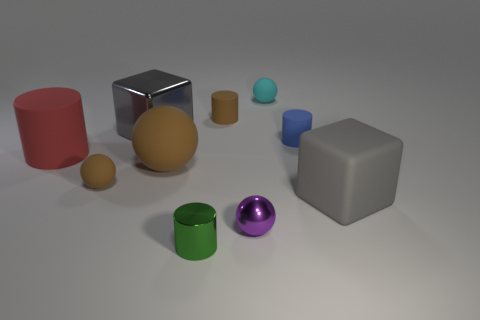Subtract all shiny spheres. How many spheres are left? 3 Subtract all green cylinders. How many cylinders are left? 3 Subtract all cylinders. How many objects are left? 6 Subtract all small cyan rubber things. Subtract all blocks. How many objects are left? 7 Add 9 big red things. How many big red things are left? 10 Add 6 large red cylinders. How many large red cylinders exist? 7 Subtract 1 red cylinders. How many objects are left? 9 Subtract 1 cubes. How many cubes are left? 1 Subtract all gray cylinders. Subtract all gray cubes. How many cylinders are left? 4 Subtract all gray cylinders. How many green blocks are left? 0 